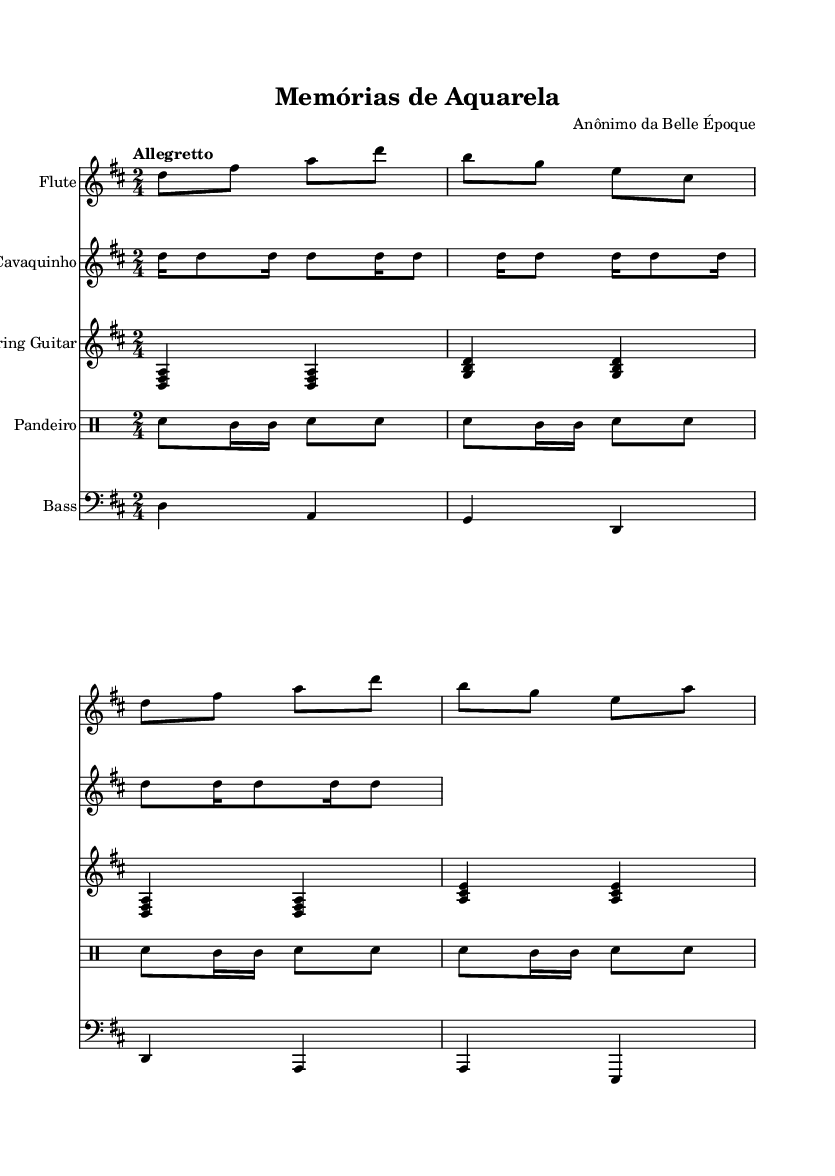What is the key signature of this music? The key signature is associated with D major, indicated by the two sharps (F# and C#). These sharps are represented at the beginning of the staff.
Answer: D major What is the time signature of this piece? The time signature is displayed at the beginning of the sheet music, which shows 2/4. This means there are 2 beats per measure and the quarter note gets one beat.
Answer: 2/4 What is the tempo indication for the music? The tempo is specified as "Allegretto," which indicates a moderate tempo that is moderately fast. This is found in the tempo marking at the beginning of the score.
Answer: Allegretto How many repeat signs are used in the flute part? The flute part contains no repeat signs. A visual scan of the flute staff confirms this, as there are no specific symbols that indicate repetition.
Answer: 0 What instruments are featured in this composition? The score lists five instruments: Flute, Cavaquinho, 7-string Guitar, Pandeiro, and Bass. Each is clearly labeled at the beginning of its respective staff.
Answer: Flute, Cavaquinho, 7-string Guitar, Pandeiro, Bass Which instrument plays in the bass clef? The Bass part is written in the bass clef, indicated at the start of that staff. This notation shows it is a lower-pitched instrument part.
Answer: Bass What is the rhythmic pattern used in the Pandeiro part? The Pandeiro part consists of a repeating pattern of snare notes and toms. The rhythmic sequence is specifically written in 2/4 time, which can be observed in the notated drum line.
Answer: Snare and toms 